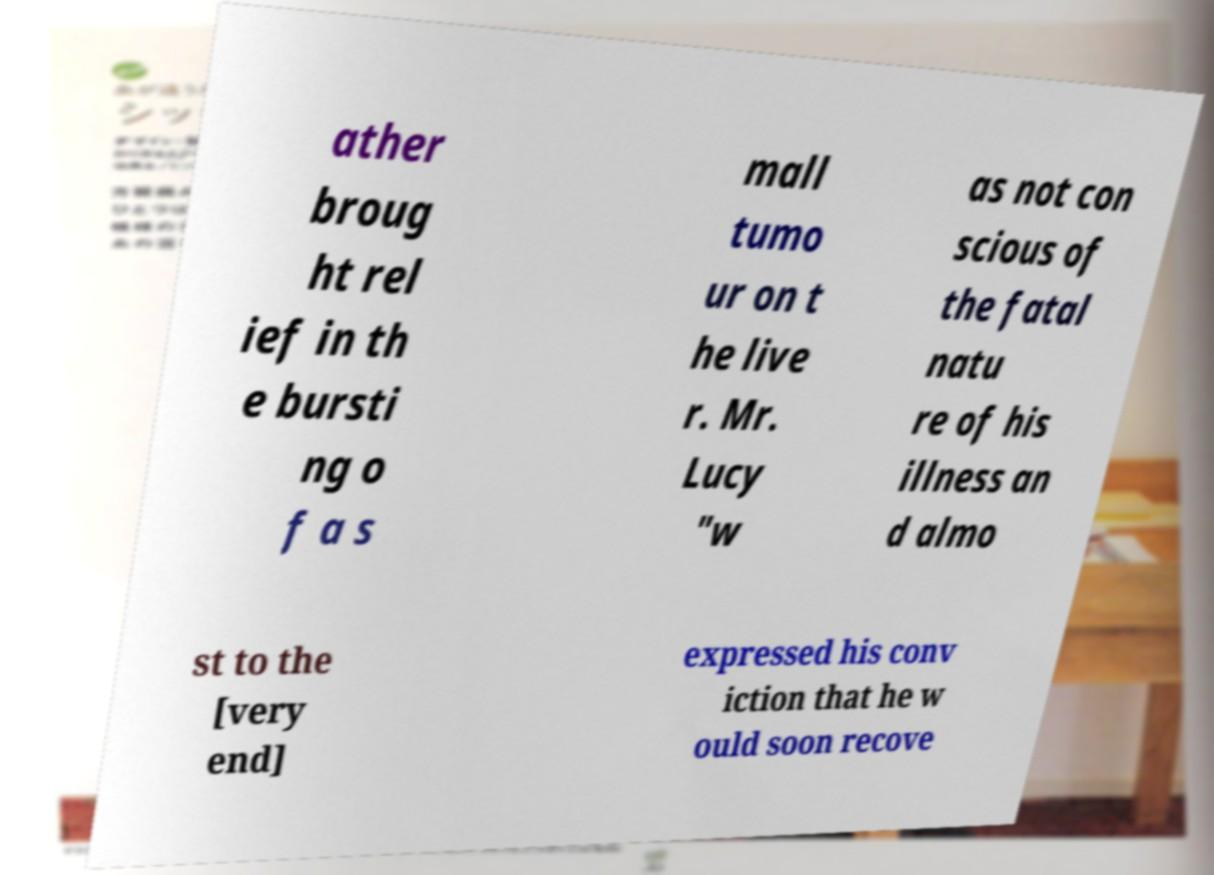Could you assist in decoding the text presented in this image and type it out clearly? ather broug ht rel ief in th e bursti ng o f a s mall tumo ur on t he live r. Mr. Lucy "w as not con scious of the fatal natu re of his illness an d almo st to the [very end] expressed his conv iction that he w ould soon recove 